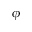Convert formula to latex. <formula><loc_0><loc_0><loc_500><loc_500>\phi</formula> 